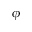Convert formula to latex. <formula><loc_0><loc_0><loc_500><loc_500>\phi</formula> 